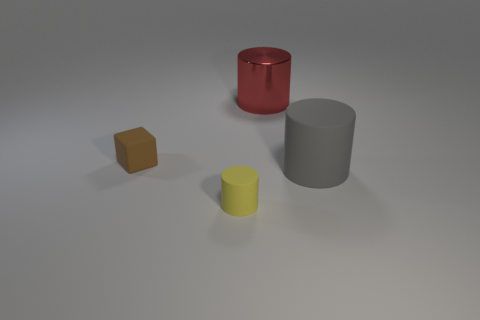Subtract all small cylinders. How many cylinders are left? 2 Subtract all red cylinders. How many cylinders are left? 2 Subtract all cylinders. How many objects are left? 1 Add 3 big red things. How many objects exist? 7 Subtract 1 blocks. How many blocks are left? 0 Subtract all brown cylinders. How many yellow cubes are left? 0 Add 2 yellow rubber things. How many yellow rubber things are left? 3 Add 1 metallic things. How many metallic things exist? 2 Subtract 1 gray cylinders. How many objects are left? 3 Subtract all purple cylinders. Subtract all cyan spheres. How many cylinders are left? 3 